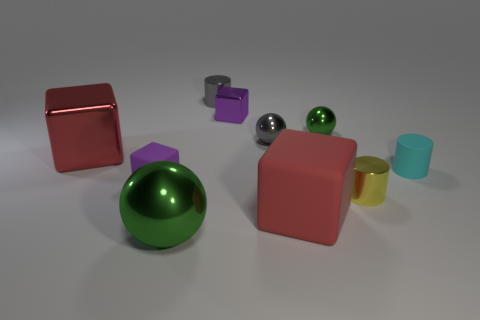There is a purple object that is behind the matte object on the right side of the tiny shiny cylinder that is right of the large rubber cube; what shape is it?
Give a very brief answer. Cube. There is a big ball that is made of the same material as the small gray cylinder; what is its color?
Provide a short and direct response. Green. What color is the tiny matte object to the right of the green sphere behind the large metal thing that is behind the tiny yellow metal cylinder?
Offer a terse response. Cyan. What number of cylinders are either small rubber objects or red rubber things?
Keep it short and to the point. 1. What material is the object that is the same color as the large matte block?
Give a very brief answer. Metal. There is a small shiny block; does it have the same color as the metallic cylinder that is in front of the large shiny block?
Ensure brevity in your answer.  No. The big metal cube is what color?
Keep it short and to the point. Red. What number of objects are either purple metallic cubes or large red metallic things?
Offer a terse response. 2. There is a gray cylinder that is the same size as the yellow cylinder; what material is it?
Your answer should be very brief. Metal. How big is the sphere in front of the tiny gray sphere?
Offer a very short reply. Large. 